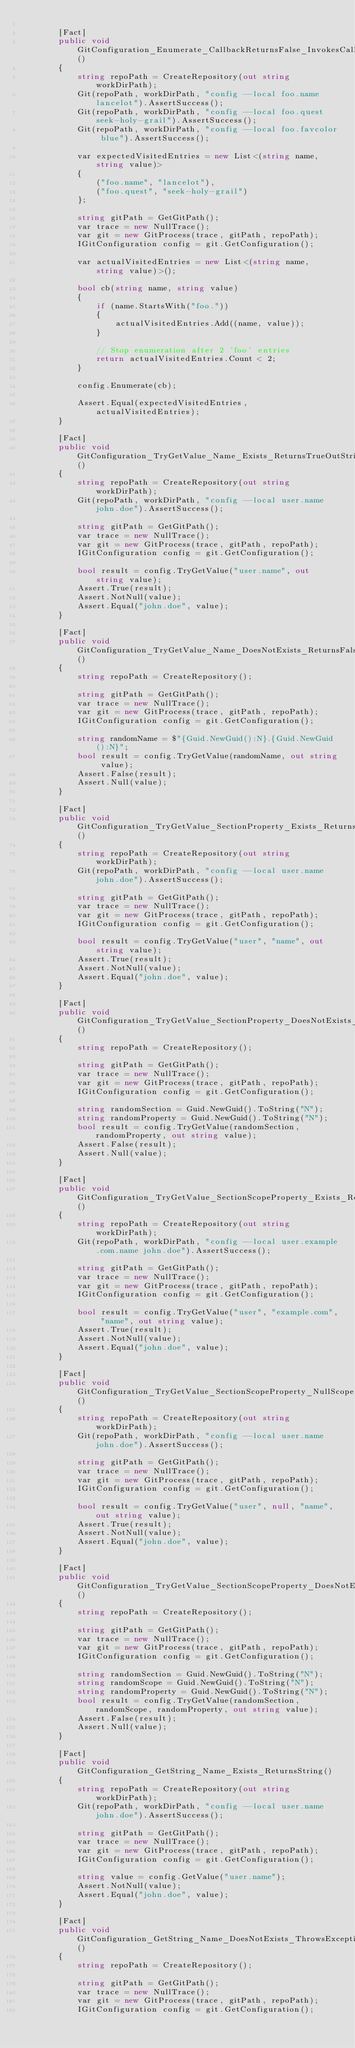<code> <loc_0><loc_0><loc_500><loc_500><_C#_>
        [Fact]
        public void GitConfiguration_Enumerate_CallbackReturnsFalse_InvokesCallbackForEachEntryUntilReturnsFalse()
        {
            string repoPath = CreateRepository(out string workDirPath);
            Git(repoPath, workDirPath, "config --local foo.name lancelot").AssertSuccess();
            Git(repoPath, workDirPath, "config --local foo.quest seek-holy-grail").AssertSuccess();
            Git(repoPath, workDirPath, "config --local foo.favcolor blue").AssertSuccess();

            var expectedVisitedEntries = new List<(string name, string value)>
            {
                ("foo.name", "lancelot"),
                ("foo.quest", "seek-holy-grail")
            };

            string gitPath = GetGitPath();
            var trace = new NullTrace();
            var git = new GitProcess(trace, gitPath, repoPath);
            IGitConfiguration config = git.GetConfiguration();

            var actualVisitedEntries = new List<(string name, string value)>();

            bool cb(string name, string value)
            {
                if (name.StartsWith("foo."))
                {
                    actualVisitedEntries.Add((name, value));
                }

                // Stop enumeration after 2 'foo' entries
                return actualVisitedEntries.Count < 2;
            }

            config.Enumerate(cb);

            Assert.Equal(expectedVisitedEntries, actualVisitedEntries);
        }

        [Fact]
        public void GitConfiguration_TryGetValue_Name_Exists_ReturnsTrueOutString()
        {
            string repoPath = CreateRepository(out string workDirPath);
            Git(repoPath, workDirPath, "config --local user.name john.doe").AssertSuccess();

            string gitPath = GetGitPath();
            var trace = new NullTrace();
            var git = new GitProcess(trace, gitPath, repoPath);
            IGitConfiguration config = git.GetConfiguration();

            bool result = config.TryGetValue("user.name", out string value);
            Assert.True(result);
            Assert.NotNull(value);
            Assert.Equal("john.doe", value);
        }

        [Fact]
        public void GitConfiguration_TryGetValue_Name_DoesNotExists_ReturnsFalse()
        {
            string repoPath = CreateRepository();

            string gitPath = GetGitPath();
            var trace = new NullTrace();
            var git = new GitProcess(trace, gitPath, repoPath);
            IGitConfiguration config = git.GetConfiguration();

            string randomName = $"{Guid.NewGuid():N}.{Guid.NewGuid():N}";
            bool result = config.TryGetValue(randomName, out string value);
            Assert.False(result);
            Assert.Null(value);
        }

        [Fact]
        public void GitConfiguration_TryGetValue_SectionProperty_Exists_ReturnsTrueOutString()
        {
            string repoPath = CreateRepository(out string workDirPath);
            Git(repoPath, workDirPath, "config --local user.name john.doe").AssertSuccess();

            string gitPath = GetGitPath();
            var trace = new NullTrace();
            var git = new GitProcess(trace, gitPath, repoPath);
            IGitConfiguration config = git.GetConfiguration();

            bool result = config.TryGetValue("user", "name", out string value);
            Assert.True(result);
            Assert.NotNull(value);
            Assert.Equal("john.doe", value);
        }

        [Fact]
        public void GitConfiguration_TryGetValue_SectionProperty_DoesNotExists_ReturnsFalse()
        {
            string repoPath = CreateRepository();

            string gitPath = GetGitPath();
            var trace = new NullTrace();
            var git = new GitProcess(trace, gitPath, repoPath);
            IGitConfiguration config = git.GetConfiguration();

            string randomSection = Guid.NewGuid().ToString("N");
            string randomProperty = Guid.NewGuid().ToString("N");
            bool result = config.TryGetValue(randomSection, randomProperty, out string value);
            Assert.False(result);
            Assert.Null(value);
        }

        [Fact]
        public void GitConfiguration_TryGetValue_SectionScopeProperty_Exists_ReturnsTrueOutString()
        {
            string repoPath = CreateRepository(out string workDirPath);
            Git(repoPath, workDirPath, "config --local user.example.com.name john.doe").AssertSuccess();

            string gitPath = GetGitPath();
            var trace = new NullTrace();
            var git = new GitProcess(trace, gitPath, repoPath);
            IGitConfiguration config = git.GetConfiguration();

            bool result = config.TryGetValue("user", "example.com", "name", out string value);
            Assert.True(result);
            Assert.NotNull(value);
            Assert.Equal("john.doe", value);
        }

        [Fact]
        public void GitConfiguration_TryGetValue_SectionScopeProperty_NullScope_ReturnsTrueOutUnscopedString()
        {
            string repoPath = CreateRepository(out string workDirPath);
            Git(repoPath, workDirPath, "config --local user.name john.doe").AssertSuccess();

            string gitPath = GetGitPath();
            var trace = new NullTrace();
            var git = new GitProcess(trace, gitPath, repoPath);
            IGitConfiguration config = git.GetConfiguration();

            bool result = config.TryGetValue("user", null, "name", out string value);
            Assert.True(result);
            Assert.NotNull(value);
            Assert.Equal("john.doe", value);
        }

        [Fact]
        public void GitConfiguration_TryGetValue_SectionScopeProperty_DoesNotExists_ReturnsFalse()
        {
            string repoPath = CreateRepository();

            string gitPath = GetGitPath();
            var trace = new NullTrace();
            var git = new GitProcess(trace, gitPath, repoPath);
            IGitConfiguration config = git.GetConfiguration();

            string randomSection = Guid.NewGuid().ToString("N");
            string randomScope = Guid.NewGuid().ToString("N");
            string randomProperty = Guid.NewGuid().ToString("N");
            bool result = config.TryGetValue(randomSection, randomScope, randomProperty, out string value);
            Assert.False(result);
            Assert.Null(value);
        }

        [Fact]
        public void GitConfiguration_GetString_Name_Exists_ReturnsString()
        {
            string repoPath = CreateRepository(out string workDirPath);
            Git(repoPath, workDirPath, "config --local user.name john.doe").AssertSuccess();

            string gitPath = GetGitPath();
            var trace = new NullTrace();
            var git = new GitProcess(trace, gitPath, repoPath);
            IGitConfiguration config = git.GetConfiguration();

            string value = config.GetValue("user.name");
            Assert.NotNull(value);
            Assert.Equal("john.doe", value);
        }

        [Fact]
        public void GitConfiguration_GetString_Name_DoesNotExists_ThrowsException()
        {
            string repoPath = CreateRepository();

            string gitPath = GetGitPath();
            var trace = new NullTrace();
            var git = new GitProcess(trace, gitPath, repoPath);
            IGitConfiguration config = git.GetConfiguration();
</code> 